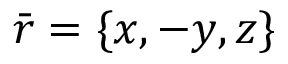Convert formula to latex. <formula><loc_0><loc_0><loc_500><loc_500>\bar { r } = \{ x , - y , z \}</formula> 